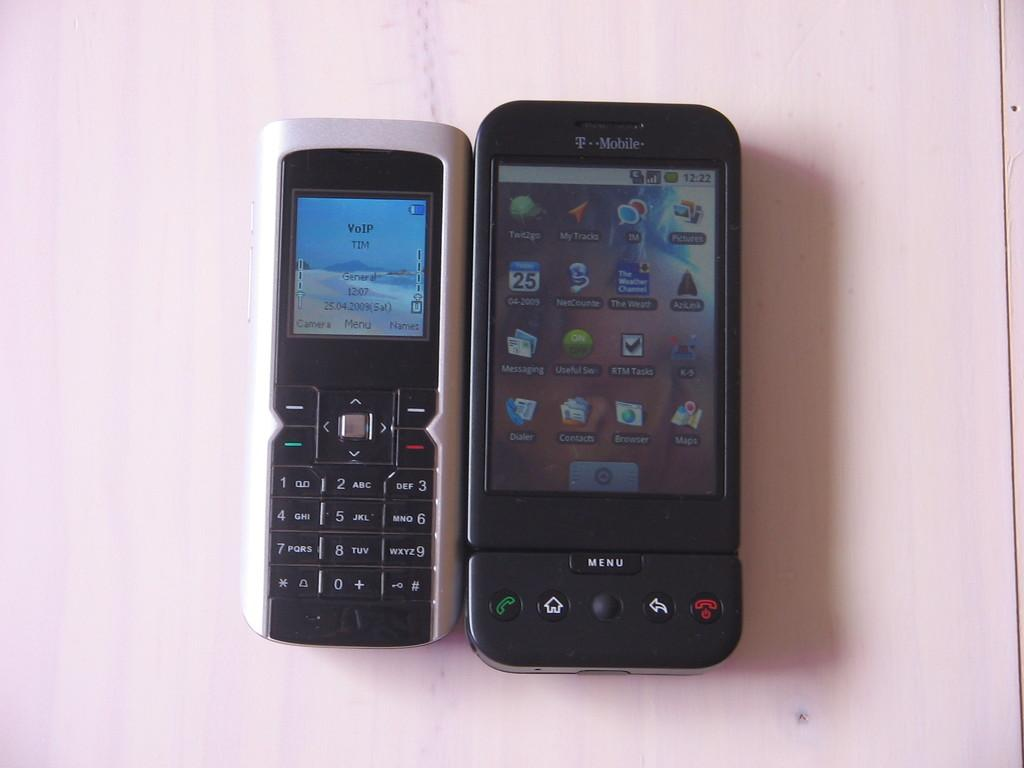Provide a one-sentence caption for the provided image. An old fashioned phone next to a new one, the new one has t he word Menu at the bottom. 